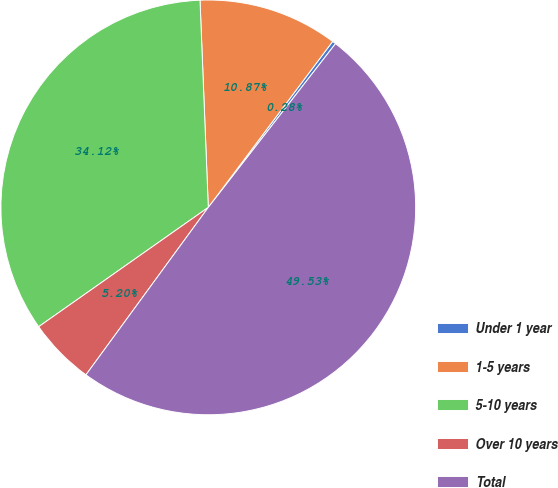<chart> <loc_0><loc_0><loc_500><loc_500><pie_chart><fcel>Under 1 year<fcel>1-5 years<fcel>5-10 years<fcel>Over 10 years<fcel>Total<nl><fcel>0.28%<fcel>10.87%<fcel>34.12%<fcel>5.2%<fcel>49.53%<nl></chart> 